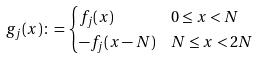<formula> <loc_0><loc_0><loc_500><loc_500>g _ { j } ( x ) & \colon = \begin{cases} f _ { j } ( x ) & 0 \leq x < N \\ - f _ { j } ( x - N ) & N \leq x < 2 N \end{cases}</formula> 